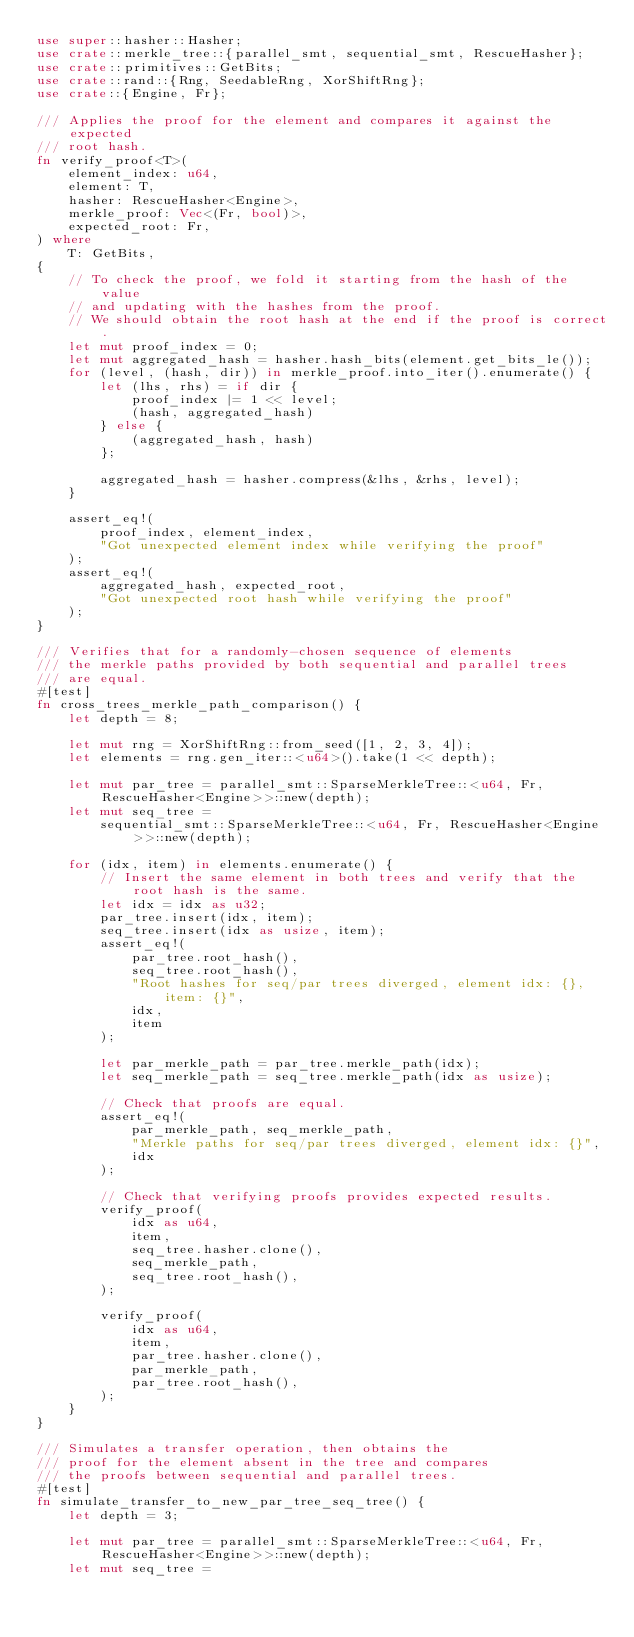<code> <loc_0><loc_0><loc_500><loc_500><_Rust_>use super::hasher::Hasher;
use crate::merkle_tree::{parallel_smt, sequential_smt, RescueHasher};
use crate::primitives::GetBits;
use crate::rand::{Rng, SeedableRng, XorShiftRng};
use crate::{Engine, Fr};

/// Applies the proof for the element and compares it against the expected
/// root hash.
fn verify_proof<T>(
    element_index: u64,
    element: T,
    hasher: RescueHasher<Engine>,
    merkle_proof: Vec<(Fr, bool)>,
    expected_root: Fr,
) where
    T: GetBits,
{
    // To check the proof, we fold it starting from the hash of the value
    // and updating with the hashes from the proof.
    // We should obtain the root hash at the end if the proof is correct.
    let mut proof_index = 0;
    let mut aggregated_hash = hasher.hash_bits(element.get_bits_le());
    for (level, (hash, dir)) in merkle_proof.into_iter().enumerate() {
        let (lhs, rhs) = if dir {
            proof_index |= 1 << level;
            (hash, aggregated_hash)
        } else {
            (aggregated_hash, hash)
        };

        aggregated_hash = hasher.compress(&lhs, &rhs, level);
    }

    assert_eq!(
        proof_index, element_index,
        "Got unexpected element index while verifying the proof"
    );
    assert_eq!(
        aggregated_hash, expected_root,
        "Got unexpected root hash while verifying the proof"
    );
}

/// Verifies that for a randomly-chosen sequence of elements
/// the merkle paths provided by both sequential and parallel trees
/// are equal.
#[test]
fn cross_trees_merkle_path_comparison() {
    let depth = 8;

    let mut rng = XorShiftRng::from_seed([1, 2, 3, 4]);
    let elements = rng.gen_iter::<u64>().take(1 << depth);

    let mut par_tree = parallel_smt::SparseMerkleTree::<u64, Fr, RescueHasher<Engine>>::new(depth);
    let mut seq_tree =
        sequential_smt::SparseMerkleTree::<u64, Fr, RescueHasher<Engine>>::new(depth);

    for (idx, item) in elements.enumerate() {
        // Insert the same element in both trees and verify that the root hash is the same.
        let idx = idx as u32;
        par_tree.insert(idx, item);
        seq_tree.insert(idx as usize, item);
        assert_eq!(
            par_tree.root_hash(),
            seq_tree.root_hash(),
            "Root hashes for seq/par trees diverged, element idx: {}, item: {}",
            idx,
            item
        );

        let par_merkle_path = par_tree.merkle_path(idx);
        let seq_merkle_path = seq_tree.merkle_path(idx as usize);

        // Check that proofs are equal.
        assert_eq!(
            par_merkle_path, seq_merkle_path,
            "Merkle paths for seq/par trees diverged, element idx: {}",
            idx
        );

        // Check that verifying proofs provides expected results.
        verify_proof(
            idx as u64,
            item,
            seq_tree.hasher.clone(),
            seq_merkle_path,
            seq_tree.root_hash(),
        );

        verify_proof(
            idx as u64,
            item,
            par_tree.hasher.clone(),
            par_merkle_path,
            par_tree.root_hash(),
        );
    }
}

/// Simulates a transfer operation, then obtains the
/// proof for the element absent in the tree and compares
/// the proofs between sequential and parallel trees.
#[test]
fn simulate_transfer_to_new_par_tree_seq_tree() {
    let depth = 3;

    let mut par_tree = parallel_smt::SparseMerkleTree::<u64, Fr, RescueHasher<Engine>>::new(depth);
    let mut seq_tree =</code> 